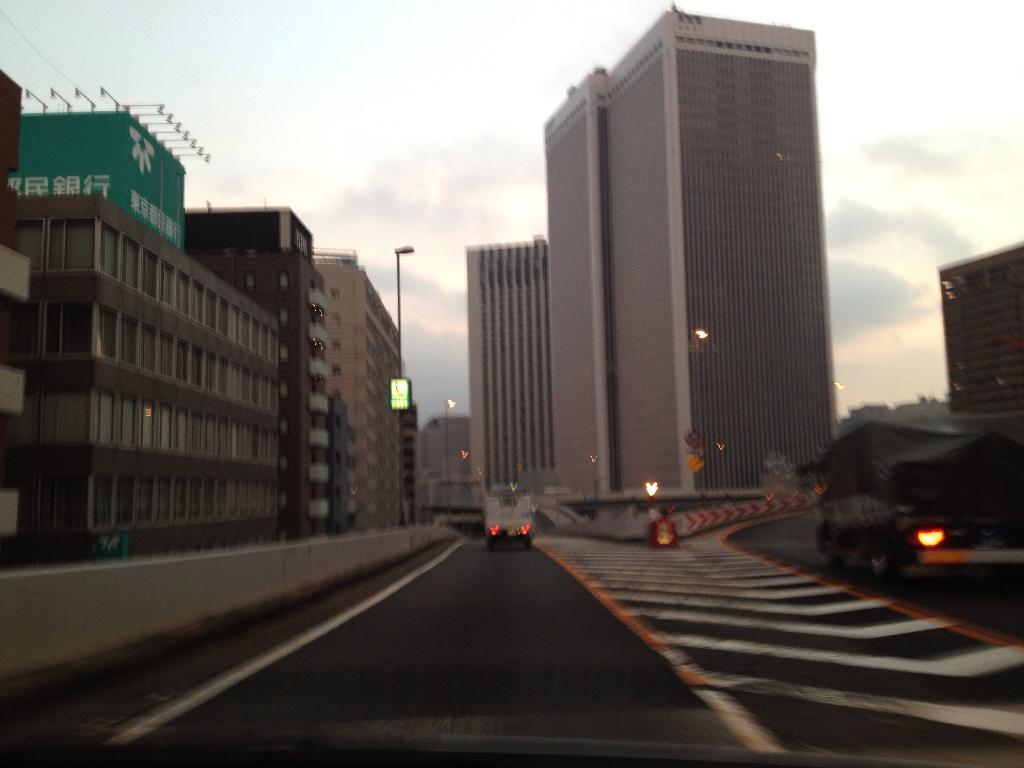Describe this image in one or two sentences. In the center of the image there is road. There are vehicles. In the background of the image there are buildings, pole. At the top of the image there is sky. 